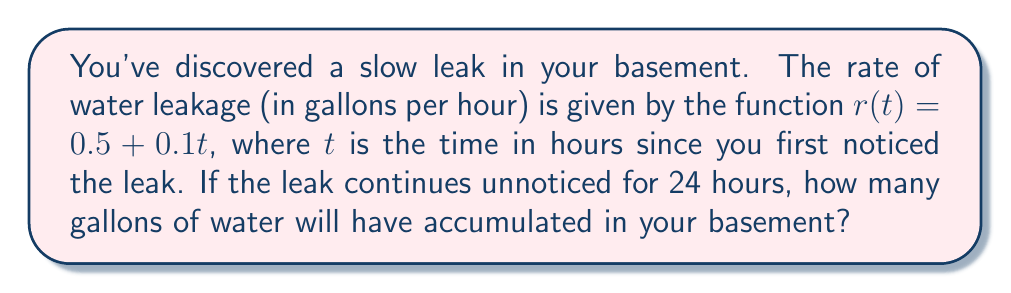Give your solution to this math problem. To solve this problem, we need to calculate the total volume of water leaked over the 24-hour period. This can be done using an integral.

1) The rate of leakage $r(t)$ is given as a function of time:
   $r(t) = 0.5 + 0.1t$ gallons/hour

2) To find the total volume, we need to integrate this rate over the given time period:
   $V = \int_0^{24} r(t) dt$

3) Substituting the function:
   $V = \int_0^{24} (0.5 + 0.1t) dt$

4) We can split this into two integrals:
   $V = \int_0^{24} 0.5 dt + \int_0^{24} 0.1t dt$

5) Integrating:
   $V = 0.5t \big|_0^{24} + 0.05t^2 \big|_0^{24}$

6) Evaluating the limits:
   $V = (0.5 \cdot 24 - 0.5 \cdot 0) + (0.05 \cdot 24^2 - 0.05 \cdot 0^2)$

7) Simplifying:
   $V = 12 + 28.8 = 40.8$

Therefore, 40.8 gallons of water will have accumulated in your basement after 24 hours.
Answer: 40.8 gallons 